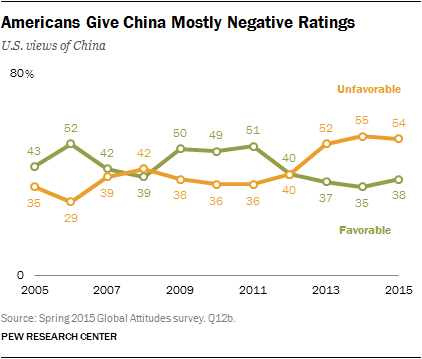Mention a couple of crucial points in this snapshot. There are 6 values in the "Unfavorable" graph that are below 40. The value of Favorable 38 in 2015 is yes. 